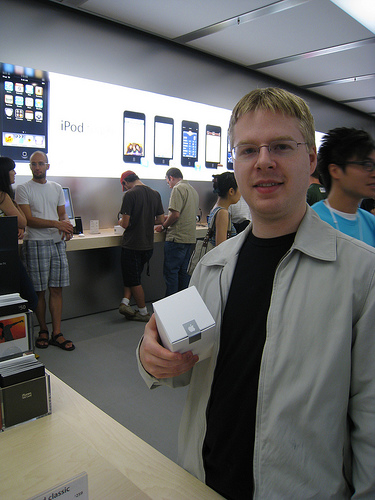<image>
Is the box next to the man? No. The box is not positioned next to the man. They are located in different areas of the scene. Is the jacket on the person? No. The jacket is not positioned on the person. They may be near each other, but the jacket is not supported by or resting on top of the person. 